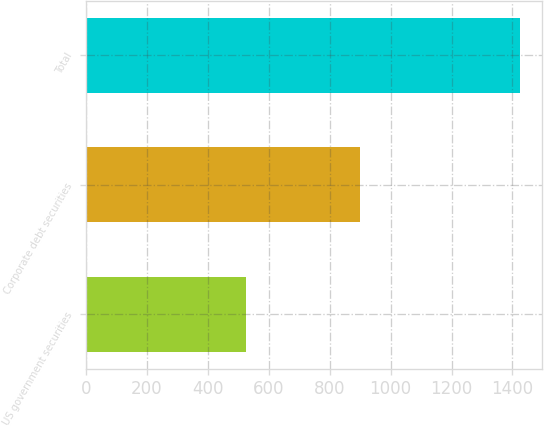<chart> <loc_0><loc_0><loc_500><loc_500><bar_chart><fcel>US government securities<fcel>Corporate debt securities<fcel>Total<nl><fcel>525<fcel>900<fcel>1425<nl></chart> 